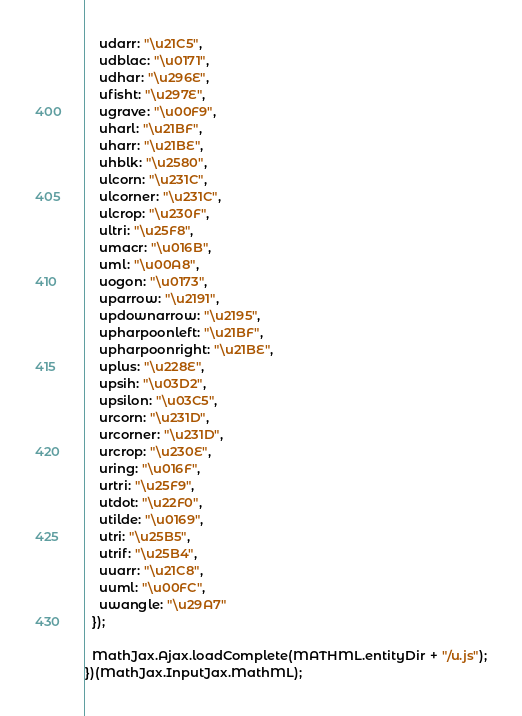<code> <loc_0><loc_0><loc_500><loc_500><_JavaScript_>    udarr: "\u21C5",
    udblac: "\u0171",
    udhar: "\u296E",
    ufisht: "\u297E",
    ugrave: "\u00F9",
    uharl: "\u21BF",
    uharr: "\u21BE",
    uhblk: "\u2580",
    ulcorn: "\u231C",
    ulcorner: "\u231C",
    ulcrop: "\u230F",
    ultri: "\u25F8",
    umacr: "\u016B",
    uml: "\u00A8",
    uogon: "\u0173",
    uparrow: "\u2191",
    updownarrow: "\u2195",
    upharpoonleft: "\u21BF",
    upharpoonright: "\u21BE",
    uplus: "\u228E",
    upsih: "\u03D2",
    upsilon: "\u03C5",
    urcorn: "\u231D",
    urcorner: "\u231D",
    urcrop: "\u230E",
    uring: "\u016F",
    urtri: "\u25F9",
    utdot: "\u22F0",
    utilde: "\u0169",
    utri: "\u25B5",
    utrif: "\u25B4",
    uuarr: "\u21C8",
    uuml: "\u00FC",
    uwangle: "\u29A7"
  });

  MathJax.Ajax.loadComplete(MATHML.entityDir + "/u.js");
})(MathJax.InputJax.MathML);
</code> 